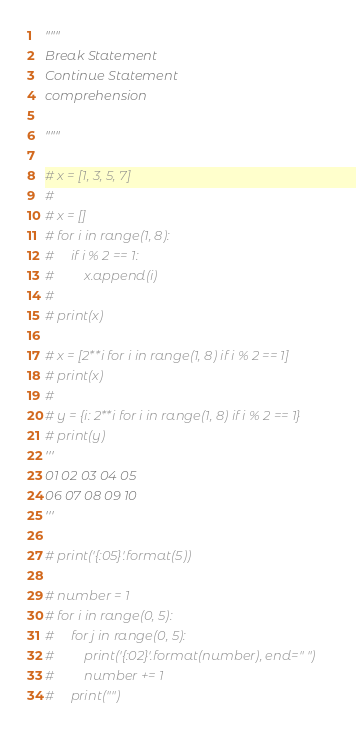Convert code to text. <code><loc_0><loc_0><loc_500><loc_500><_Python_>"""
Break Statement
Continue Statement
comprehension

"""

# x = [1, 3, 5, 7]
#
# x = []
# for i in range(1, 8):
#     if i % 2 == 1:
#         x.append(i)
#
# print(x)

# x = [2**i for i in range(1, 8) if i % 2 == 1]
# print(x)
#
# y = {i: 2**i for i in range(1, 8) if i % 2 == 1}
# print(y)
'''
01 02 03 04 05
06 07 08 09 10
'''

# print('{:05}'.format(5))

# number = 1
# for i in range(0, 5):
#     for j in range(0, 5):
#         print('{:02}'.format(number), end=" ")
#         number += 1
#     print("")
</code> 